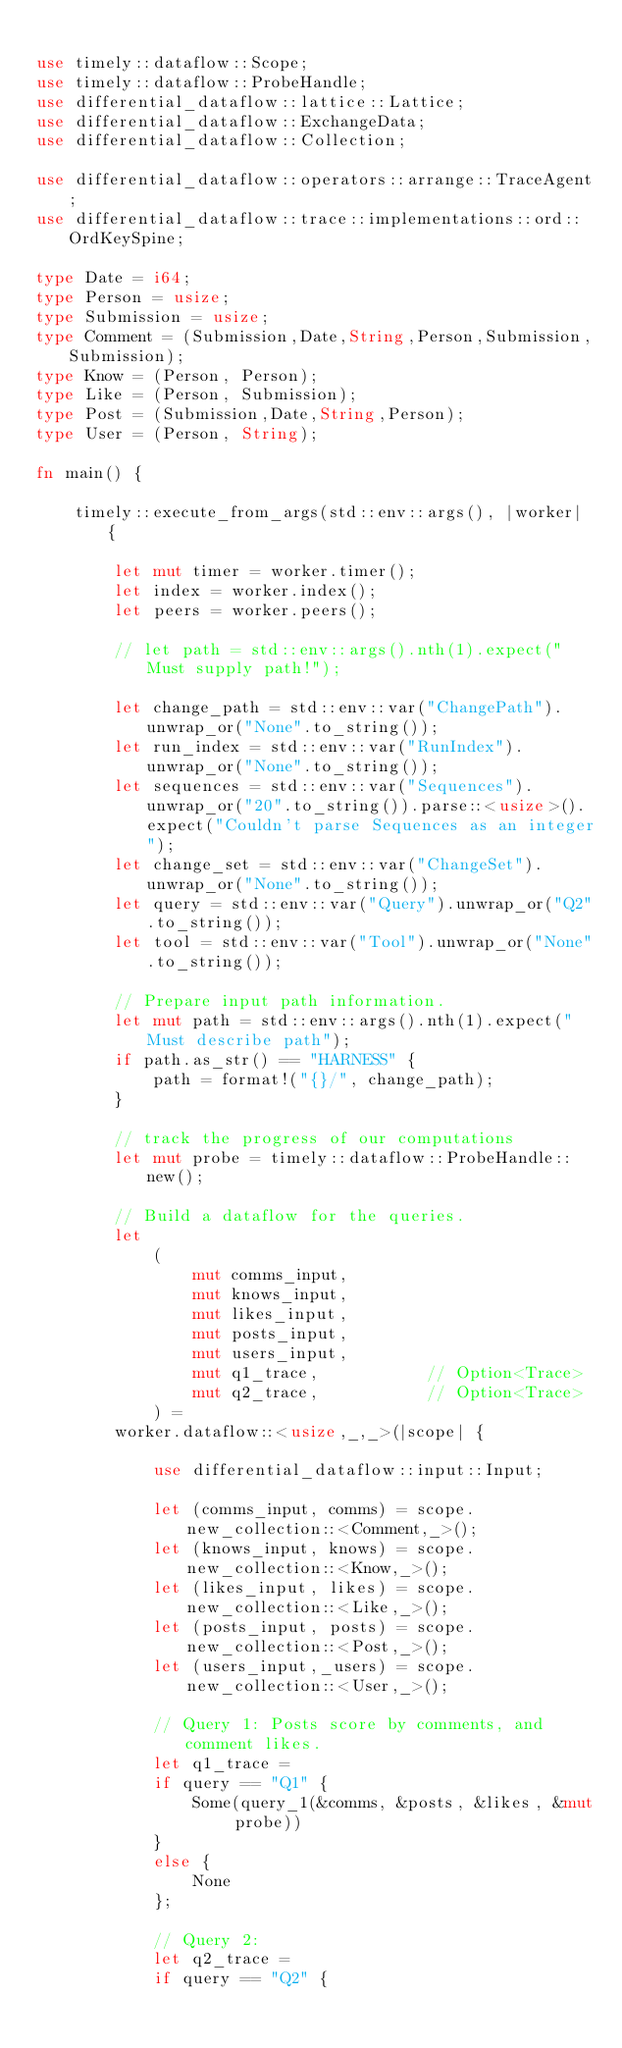Convert code to text. <code><loc_0><loc_0><loc_500><loc_500><_Rust_>
use timely::dataflow::Scope;
use timely::dataflow::ProbeHandle;
use differential_dataflow::lattice::Lattice;
use differential_dataflow::ExchangeData;
use differential_dataflow::Collection;

use differential_dataflow::operators::arrange::TraceAgent;
use differential_dataflow::trace::implementations::ord::OrdKeySpine;

type Date = i64;
type Person = usize;
type Submission = usize;
type Comment = (Submission,Date,String,Person,Submission,Submission);
type Know = (Person, Person);
type Like = (Person, Submission);
type Post = (Submission,Date,String,Person);
type User = (Person, String);

fn main() {

    timely::execute_from_args(std::env::args(), |worker| {

        let mut timer = worker.timer();
        let index = worker.index();
        let peers = worker.peers();

        // let path = std::env::args().nth(1).expect("Must supply path!");

        let change_path = std::env::var("ChangePath").unwrap_or("None".to_string());
        let run_index = std::env::var("RunIndex").unwrap_or("None".to_string());
        let sequences = std::env::var("Sequences").unwrap_or("20".to_string()).parse::<usize>().expect("Couldn't parse Sequences as an integer");
        let change_set = std::env::var("ChangeSet").unwrap_or("None".to_string());
        let query = std::env::var("Query").unwrap_or("Q2".to_string());
        let tool = std::env::var("Tool").unwrap_or("None".to_string());

        // Prepare input path information.
        let mut path = std::env::args().nth(1).expect("Must describe path");
        if path.as_str() == "HARNESS" {
            path = format!("{}/", change_path);
        }

        // track the progress of our computations
        let mut probe = timely::dataflow::ProbeHandle::new();

        // Build a dataflow for the queries.
        let 
            (
                mut comms_input, 
                mut knows_input, 
                mut likes_input, 
                mut posts_input, 
                mut users_input,
                mut q1_trace,           // Option<Trace>
                mut q2_trace,           // Option<Trace>
            ) =
        worker.dataflow::<usize,_,_>(|scope| {

            use differential_dataflow::input::Input;

            let (comms_input, comms) = scope.new_collection::<Comment,_>();
            let (knows_input, knows) = scope.new_collection::<Know,_>();
            let (likes_input, likes) = scope.new_collection::<Like,_>();
            let (posts_input, posts) = scope.new_collection::<Post,_>();
            let (users_input,_users) = scope.new_collection::<User,_>();

            // Query 1: Posts score by comments, and comment likes.
            let q1_trace = 
            if query == "Q1" {
                Some(query_1(&comms, &posts, &likes, &mut probe))
            }
            else {
                None
            };

            // Query 2: 
            let q2_trace =
            if query == "Q2" {</code> 